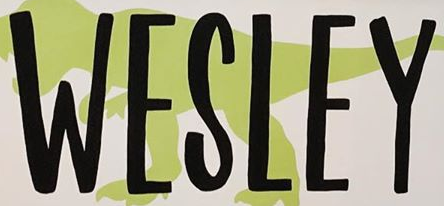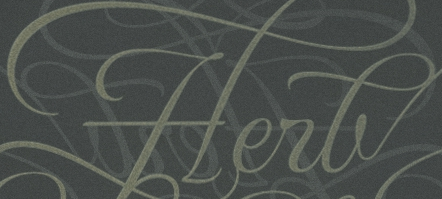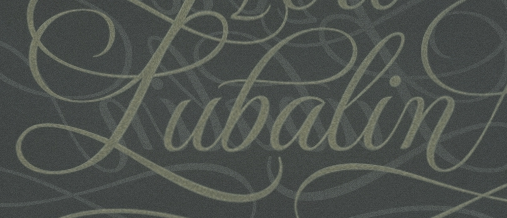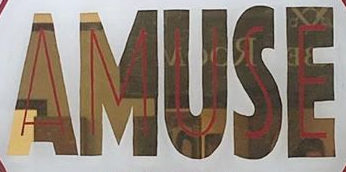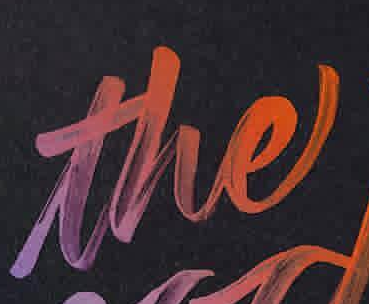What words can you see in these images in sequence, separated by a semicolon? WESLEY; Herb; Pubalin; AMUSE; the 